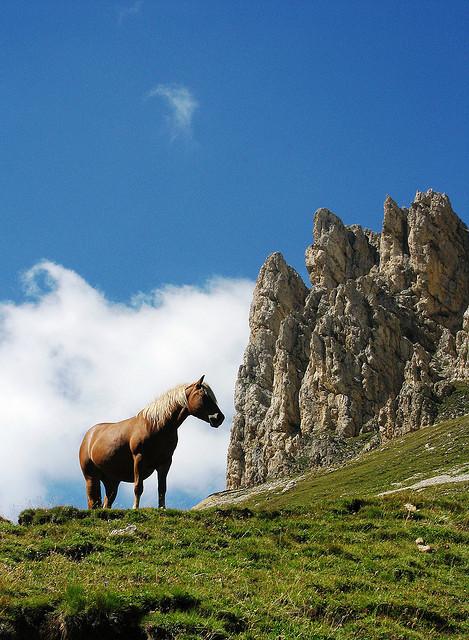Is it sunny?
Answer briefly. Yes. Is the horse saddled?
Concise answer only. No. Is it summertime in this picture?
Give a very brief answer. Yes. What kind of animals are these?
Quick response, please. Horse. What is the ground covered with?
Answer briefly. Grass. Does the horse look majestic?
Short answer required. Yes. Is there snow on the ground?
Keep it brief. No. 